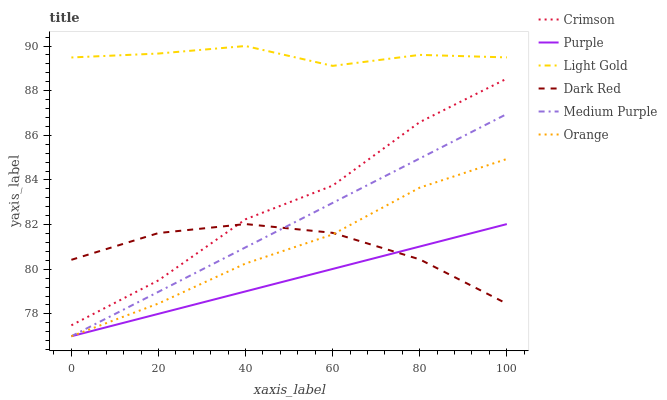Does Purple have the minimum area under the curve?
Answer yes or no. Yes. Does Light Gold have the maximum area under the curve?
Answer yes or no. Yes. Does Dark Red have the minimum area under the curve?
Answer yes or no. No. Does Dark Red have the maximum area under the curve?
Answer yes or no. No. Is Purple the smoothest?
Answer yes or no. Yes. Is Crimson the roughest?
Answer yes or no. Yes. Is Dark Red the smoothest?
Answer yes or no. No. Is Dark Red the roughest?
Answer yes or no. No. Does Dark Red have the lowest value?
Answer yes or no. No. Does Dark Red have the highest value?
Answer yes or no. No. Is Dark Red less than Light Gold?
Answer yes or no. Yes. Is Light Gold greater than Dark Red?
Answer yes or no. Yes. Does Dark Red intersect Light Gold?
Answer yes or no. No. 